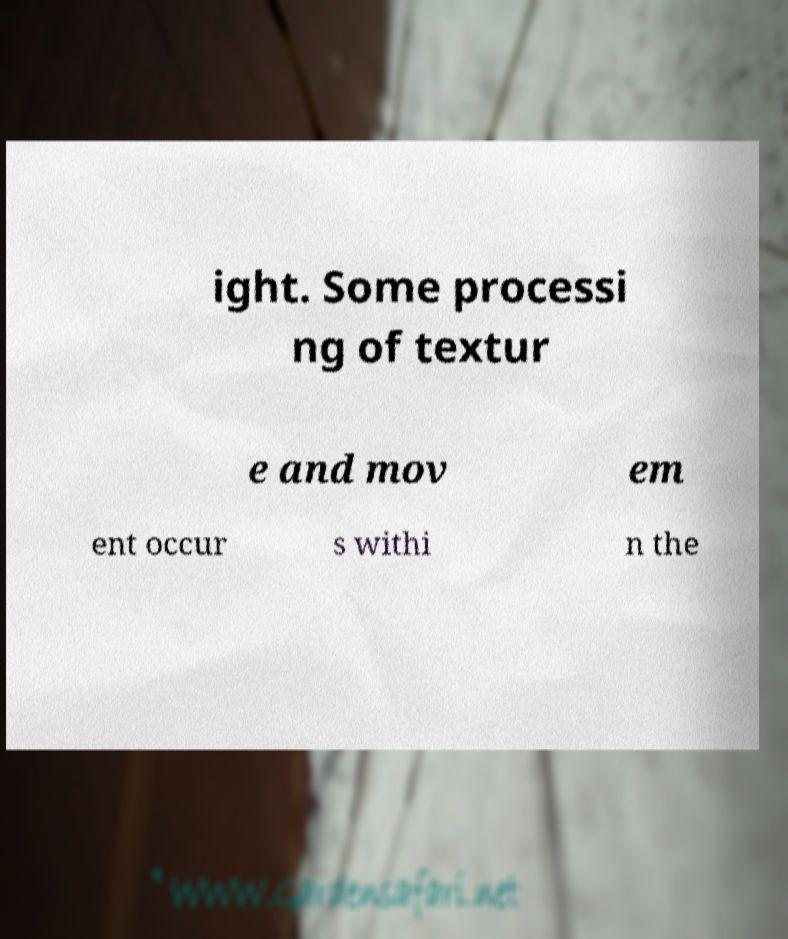There's text embedded in this image that I need extracted. Can you transcribe it verbatim? ight. Some processi ng of textur e and mov em ent occur s withi n the 